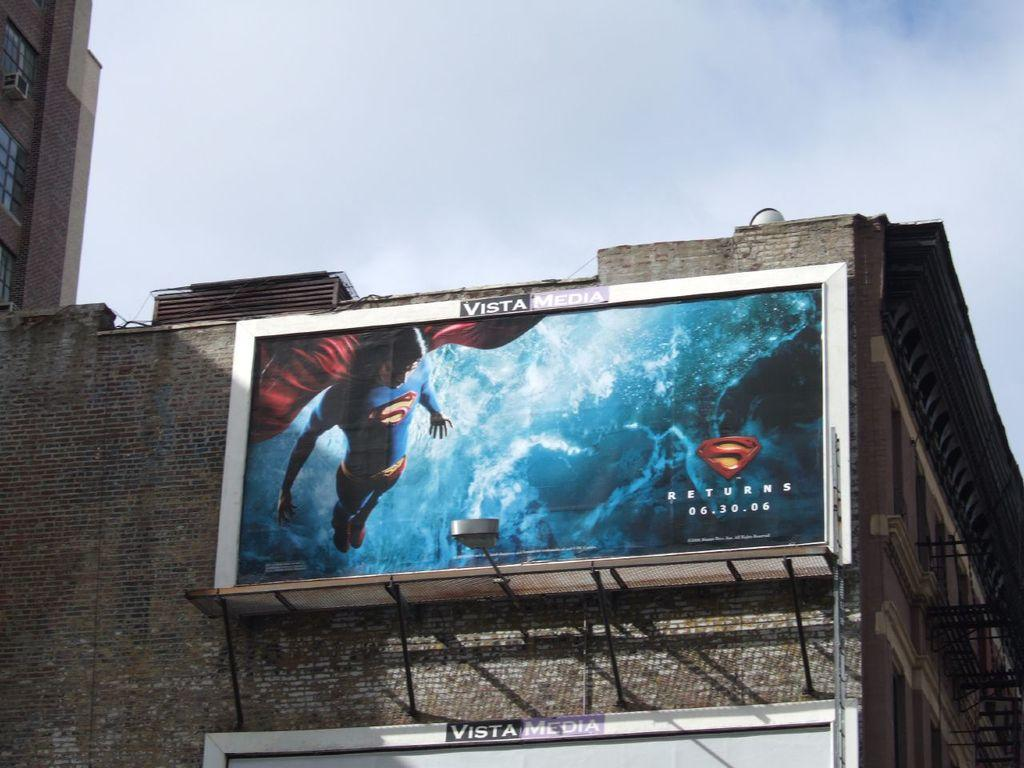<image>
Give a short and clear explanation of the subsequent image. Vista Media sign billboard on top of a building showing Superman returns 6.30.06. 